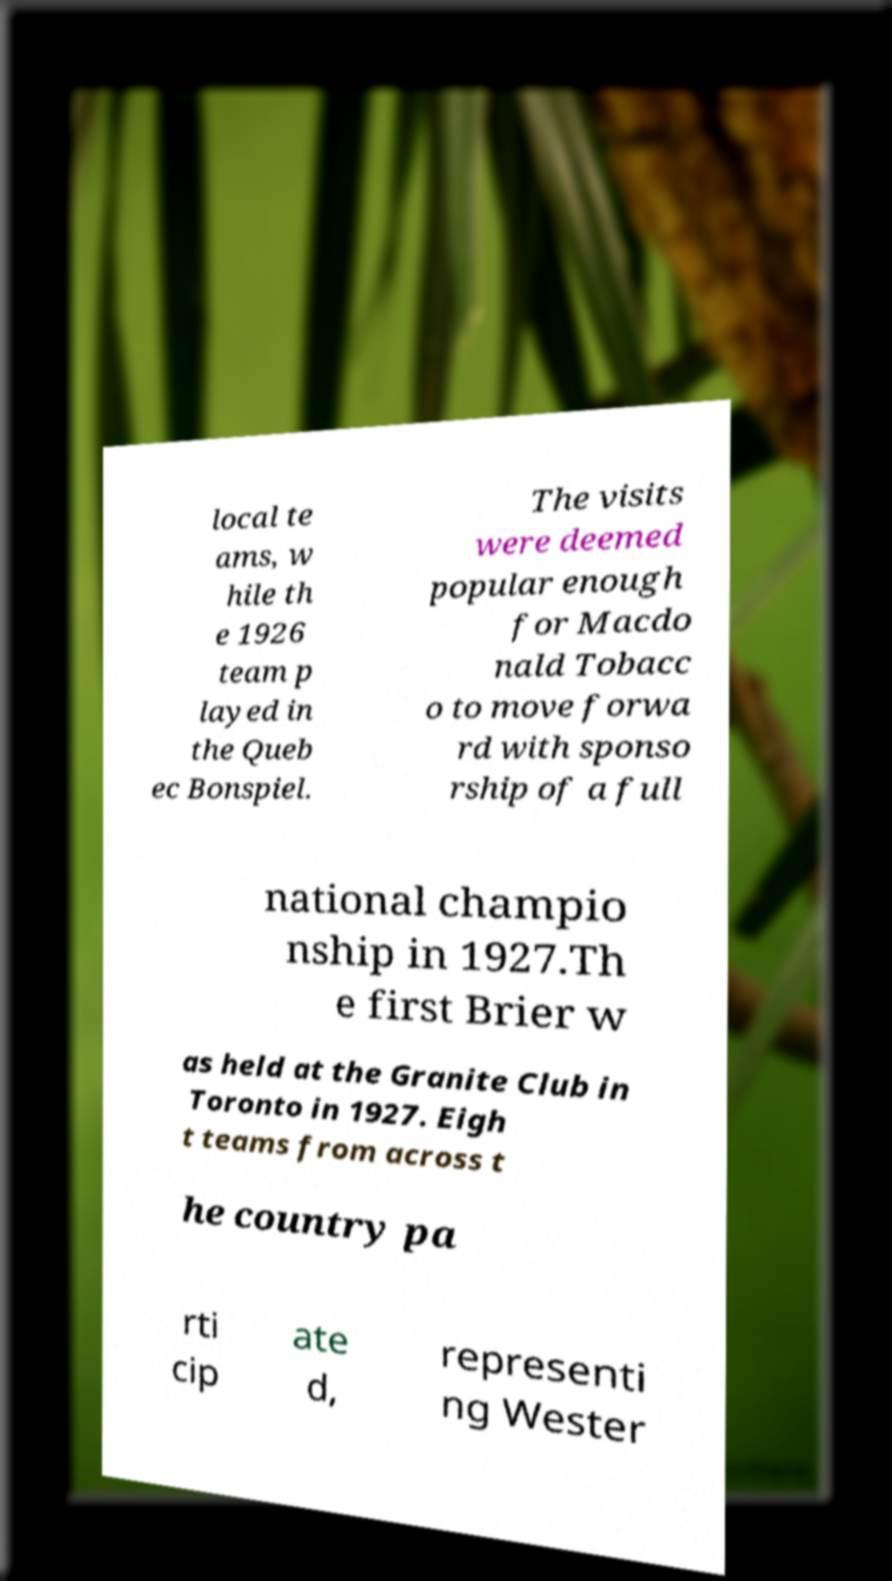What messages or text are displayed in this image? I need them in a readable, typed format. local te ams, w hile th e 1926 team p layed in the Queb ec Bonspiel. The visits were deemed popular enough for Macdo nald Tobacc o to move forwa rd with sponso rship of a full national champio nship in 1927.Th e first Brier w as held at the Granite Club in Toronto in 1927. Eigh t teams from across t he country pa rti cip ate d, representi ng Wester 